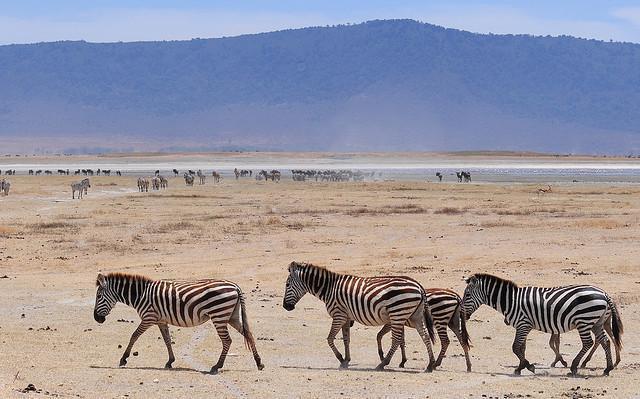How many zebras are visible?
Give a very brief answer. 4. How many cats are on the sink?
Give a very brief answer. 0. 